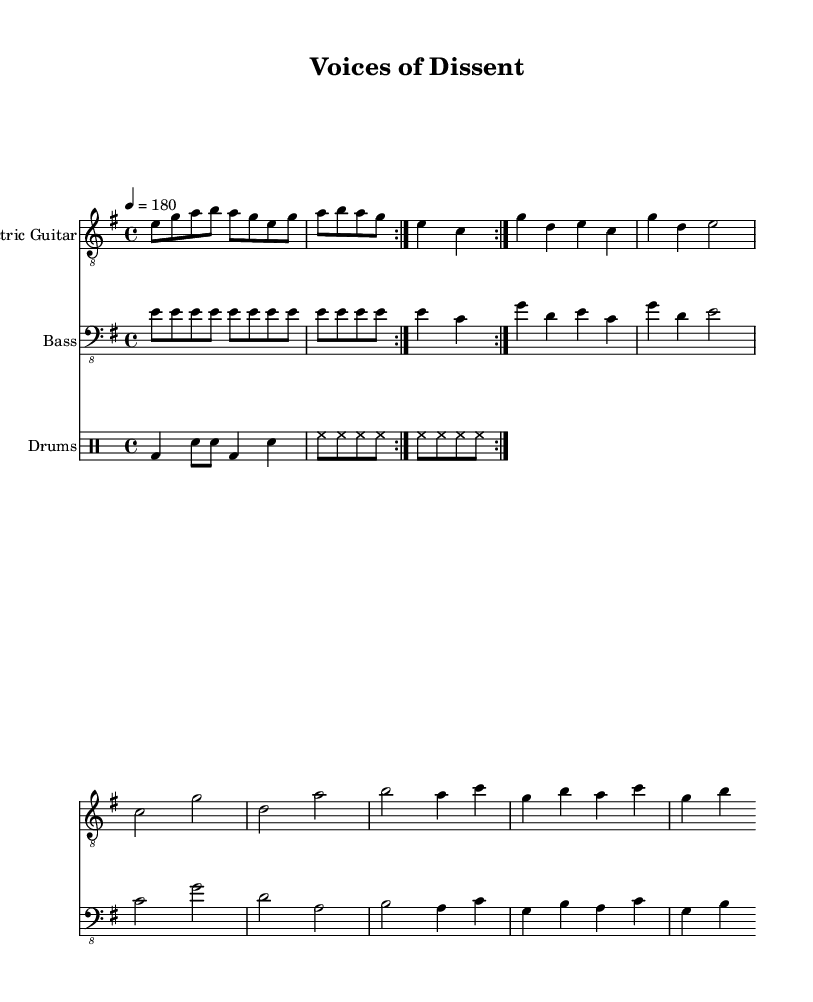What is the key signature of this music? The key signature is E minor, which has one sharp (F#) and identifies the scale around which the piece is structured.
Answer: E minor What is the time signature of the piece? The time signature indicated is 4/4, meaning there are four beats in each measure, and the quarter note gets one beat.
Answer: 4/4 What is the tempo marking? The tempo marking indicates a speed of 180 beats per minute, described with the metronome marking "4 = 180," which sets the pace for the performance.
Answer: 180 How many measures are in the main riff? The main riff is repeated twice, consisting of 10 notes per each iteration; thus, since there are 2 repetitions of the same run, it counts as 4 measures in total (2 repeats of 2 measures each).
Answer: 4 Which instrument plays the bridge? The bridge section is present in all score parts (Electric Guitar, Bass, and Drums), but it first appears in the Electric Guitar part, which is where we can identify it.
Answer: Electric Guitar What type of metal is represented in this music? This sheet music portrays "Political protest metal," characterized by themes of social injustice, government corruption, and dissent.
Answer: Political protest metal What is the highest pitch in the Electric Guitar part? The Electric Guitar reaches its highest pitch at b' (B in the treble clef) during the Chorus section of the score, making it the highest note played.
Answer: b 